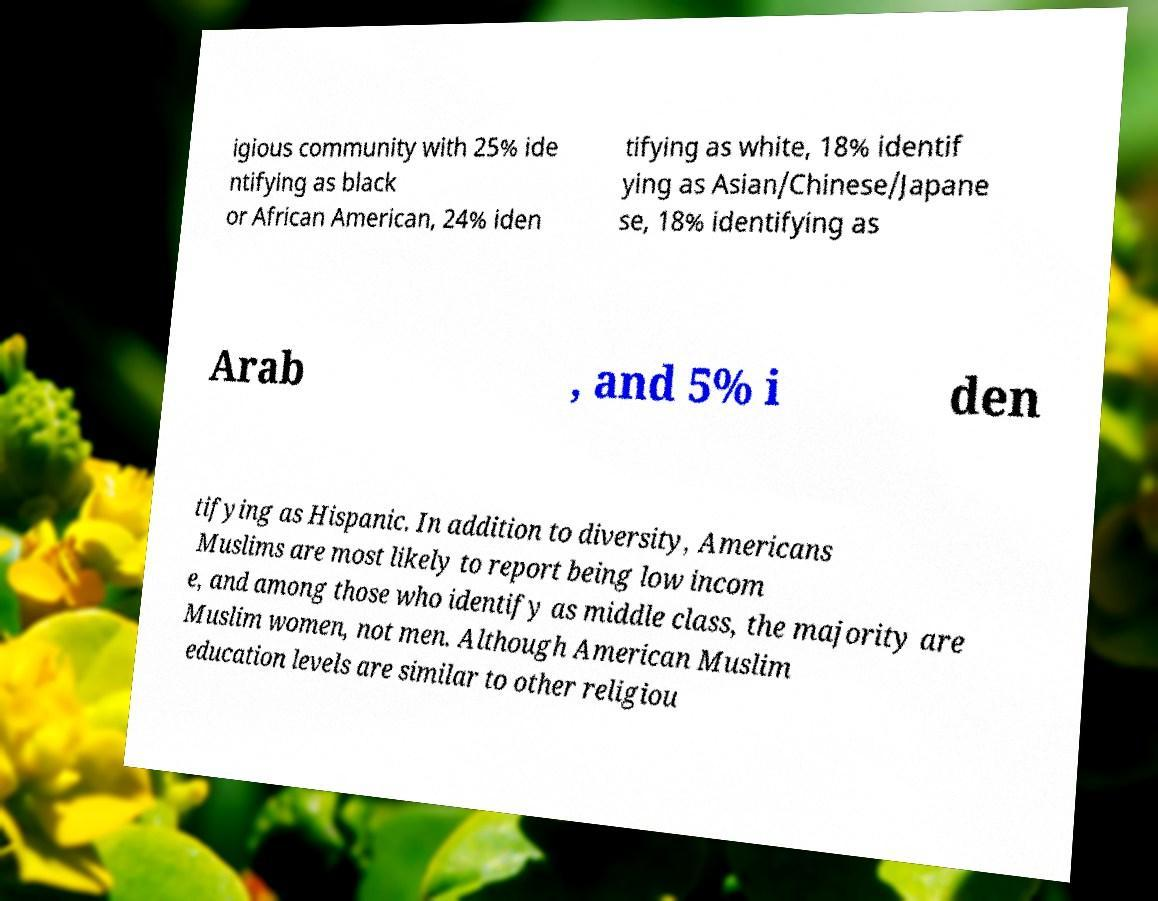Can you read and provide the text displayed in the image?This photo seems to have some interesting text. Can you extract and type it out for me? igious community with 25% ide ntifying as black or African American, 24% iden tifying as white, 18% identif ying as Asian/Chinese/Japane se, 18% identifying as Arab , and 5% i den tifying as Hispanic. In addition to diversity, Americans Muslims are most likely to report being low incom e, and among those who identify as middle class, the majority are Muslim women, not men. Although American Muslim education levels are similar to other religiou 